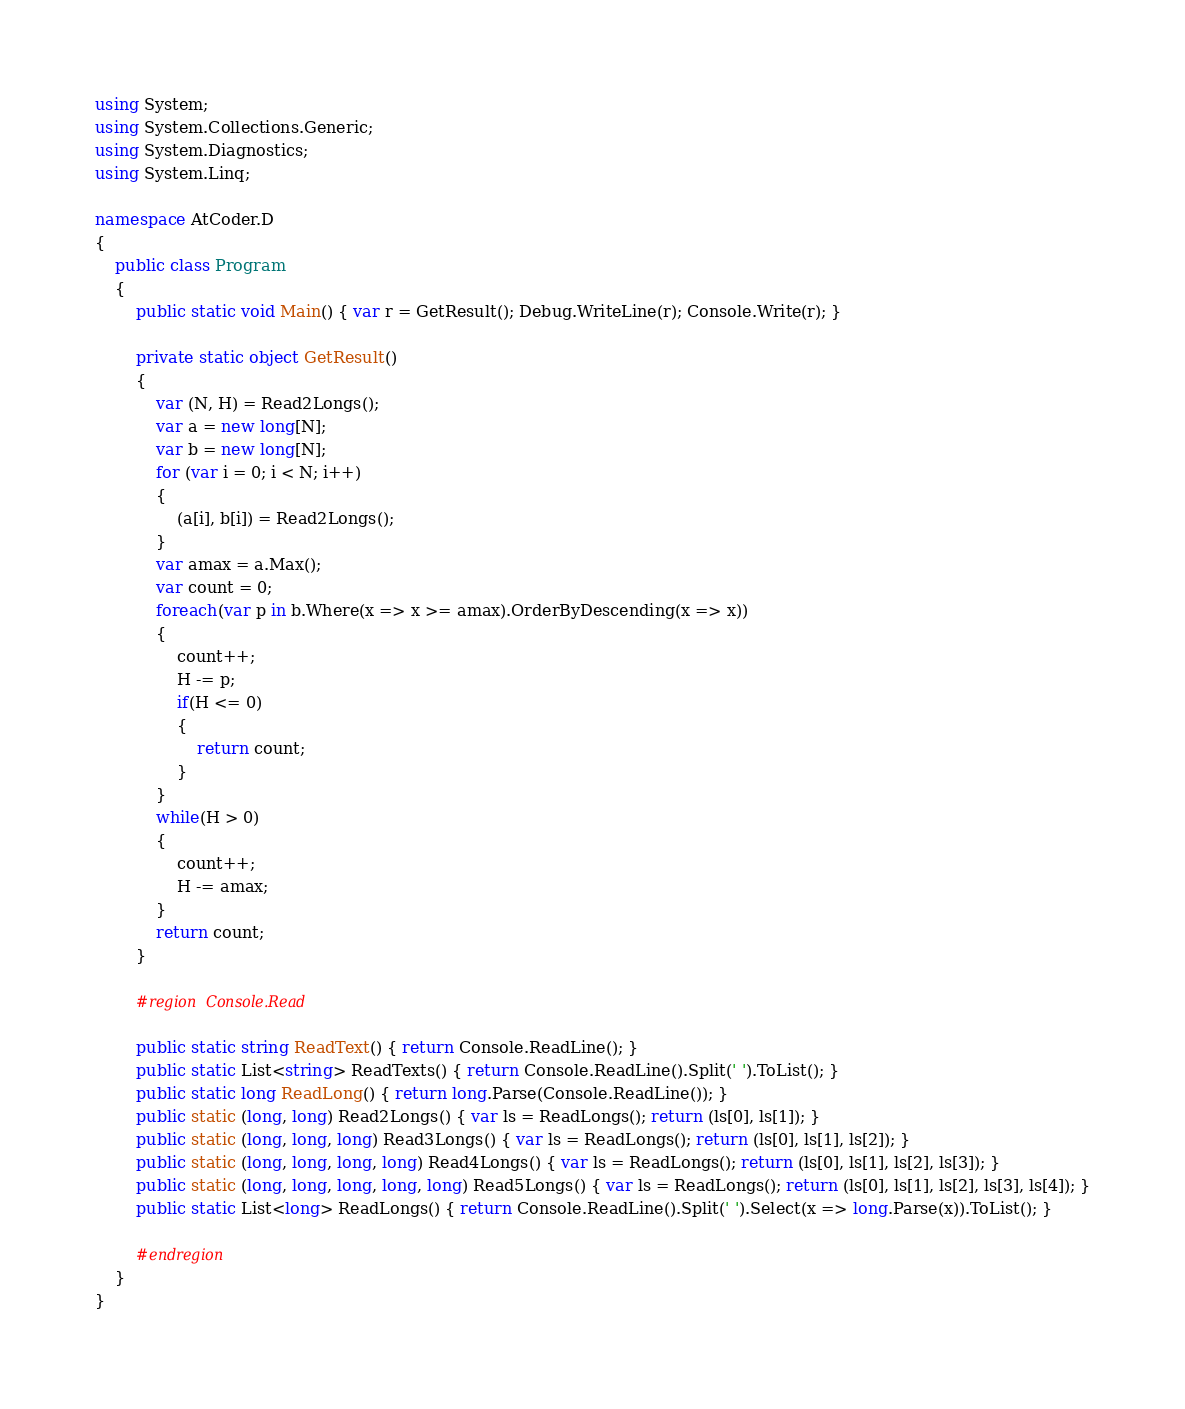Convert code to text. <code><loc_0><loc_0><loc_500><loc_500><_C#_>using System;
using System.Collections.Generic;
using System.Diagnostics;
using System.Linq;

namespace AtCoder.D
{
    public class Program
    {
        public static void Main() { var r = GetResult(); Debug.WriteLine(r); Console.Write(r); }

        private static object GetResult()
        {
            var (N, H) = Read2Longs();
            var a = new long[N];
            var b = new long[N];
            for (var i = 0; i < N; i++)
            {
                (a[i], b[i]) = Read2Longs();
            }
            var amax = a.Max();
            var count = 0;
            foreach(var p in b.Where(x => x >= amax).OrderByDescending(x => x))
            {
                count++;
                H -= p;
                if(H <= 0)
                {
                    return count;
                }
            }
            while(H > 0)
            {
                count++;
                H -= amax;
            }
            return count;
        }

        #region Console.Read

        public static string ReadText() { return Console.ReadLine(); }
        public static List<string> ReadTexts() { return Console.ReadLine().Split(' ').ToList(); }
        public static long ReadLong() { return long.Parse(Console.ReadLine()); }
        public static (long, long) Read2Longs() { var ls = ReadLongs(); return (ls[0], ls[1]); }
        public static (long, long, long) Read3Longs() { var ls = ReadLongs(); return (ls[0], ls[1], ls[2]); }
        public static (long, long, long, long) Read4Longs() { var ls = ReadLongs(); return (ls[0], ls[1], ls[2], ls[3]); }
        public static (long, long, long, long, long) Read5Longs() { var ls = ReadLongs(); return (ls[0], ls[1], ls[2], ls[3], ls[4]); }
        public static List<long> ReadLongs() { return Console.ReadLine().Split(' ').Select(x => long.Parse(x)).ToList(); }

        #endregion
    }
}
</code> 